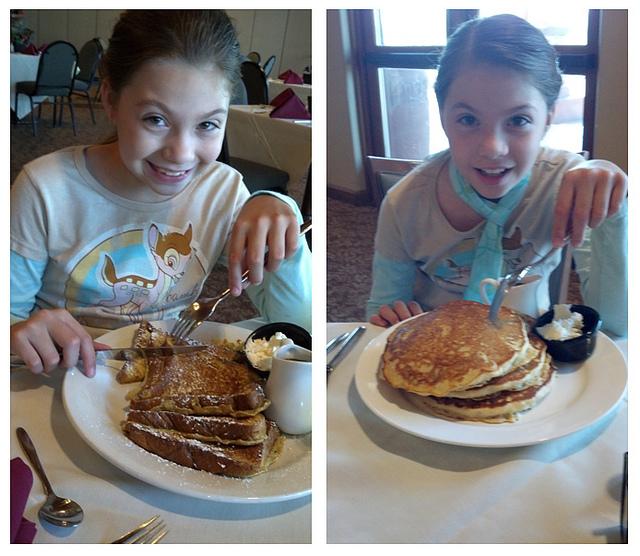Is this type of breakfast healthy?
Concise answer only. No. Where is the French toast?
Keep it brief. Left. How many pancakes are in the food stack?
Answer briefly. 3. 